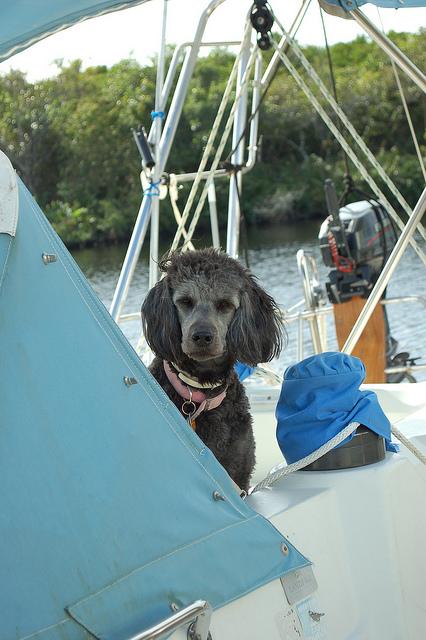Is this a poodle?
Keep it brief. Yes. Where is the dog?
Write a very short answer. Boat. What color is the dog?
Quick response, please. Black. 